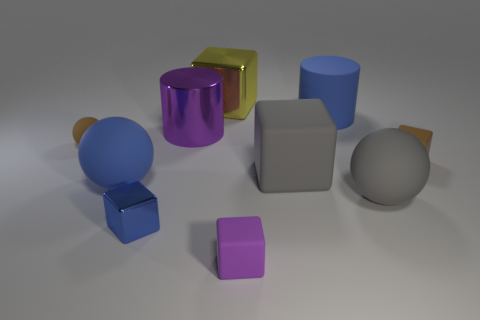There is a small ball that is made of the same material as the tiny purple cube; what is its color?
Ensure brevity in your answer.  Brown. There is a metallic cube that is on the left side of the yellow block; does it have the same size as the metal cylinder?
Your response must be concise. No. Do the yellow block and the large ball that is left of the big gray sphere have the same material?
Offer a terse response. No. What color is the large rubber sphere left of the blue block?
Ensure brevity in your answer.  Blue. There is a cylinder on the left side of the tiny purple object; is there a small brown rubber ball that is right of it?
Your answer should be compact. No. Do the small block that is in front of the blue metal block and the large shiny thing that is in front of the large metallic cube have the same color?
Give a very brief answer. Yes. What number of big things are behind the tiny brown matte block?
Your answer should be very brief. 3. How many big balls have the same color as the small shiny thing?
Offer a terse response. 1. Does the big blue object in front of the brown ball have the same material as the small purple thing?
Offer a very short reply. Yes. How many small objects are made of the same material as the large blue cylinder?
Your answer should be compact. 3. 